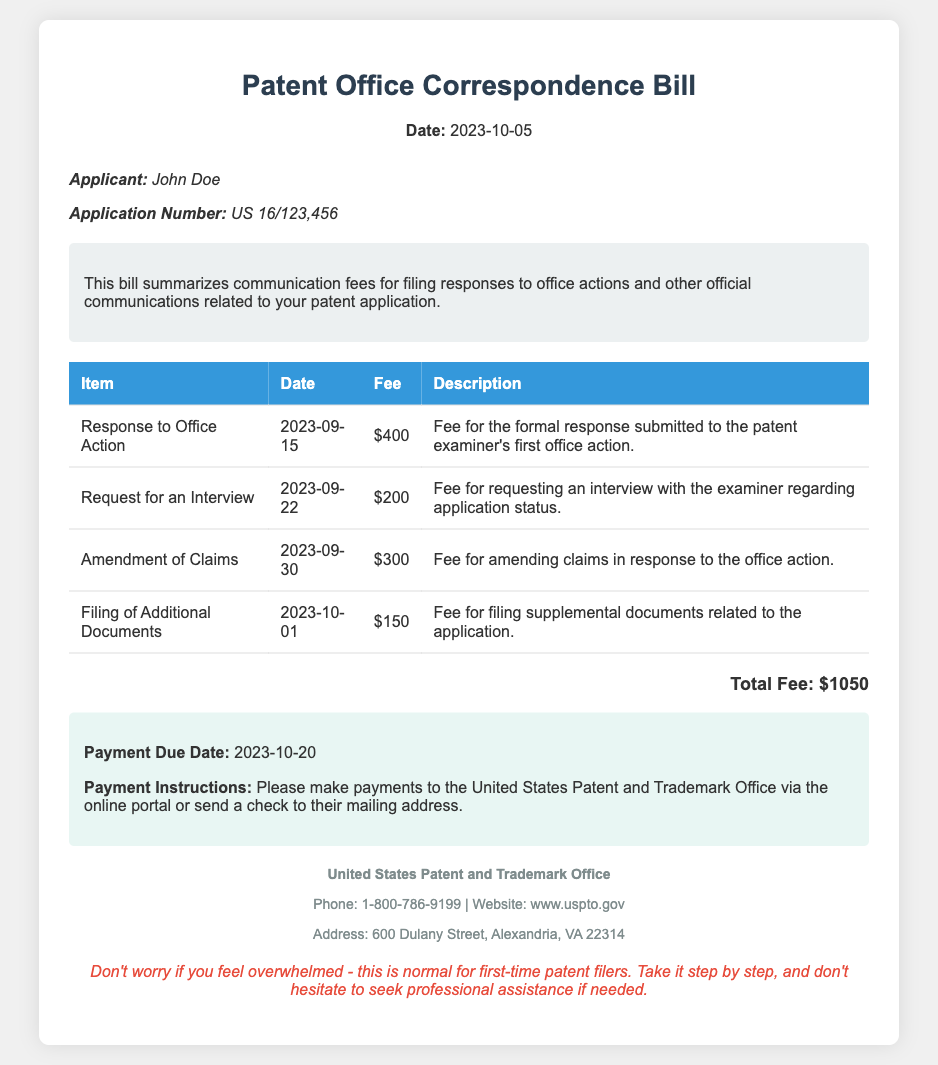what is the date of the bill? The date of the bill is specified at the top of the document.
Answer: 2023-10-05 who is the applicant? The applicant's name is indicated in the applicant info section.
Answer: John Doe what is the application number? The application number is provided alongside the applicant's name.
Answer: US 16/123,456 how much is the fee for the response to office action? The fee for the formal response is detailed in the itemized table.
Answer: $400 what is the total fee? The total fee is calculated by summing all individual fees listed in the table.
Answer: $1050 when is the payment due date? The due date for payment is indicated in the payment information section.
Answer: 2023-10-20 what are the payment instructions? The payment instructions are provided in the payment information section.
Answer: Please make payments to the United States Patent and Trademark Office via the online portal or send a check to their mailing address how many items are listed in the bill? The number of items can be counted from the table provided in the document.
Answer: 4 what is the fee for requesting an interview? The fee for the interview request is shown in the table with specific details.
Answer: $200 what should a first-time filer remember? The note at the bottom provides advice for first-time filers regarding the process.
Answer: Take it step by step, and don't hesitate to seek professional assistance if needed 